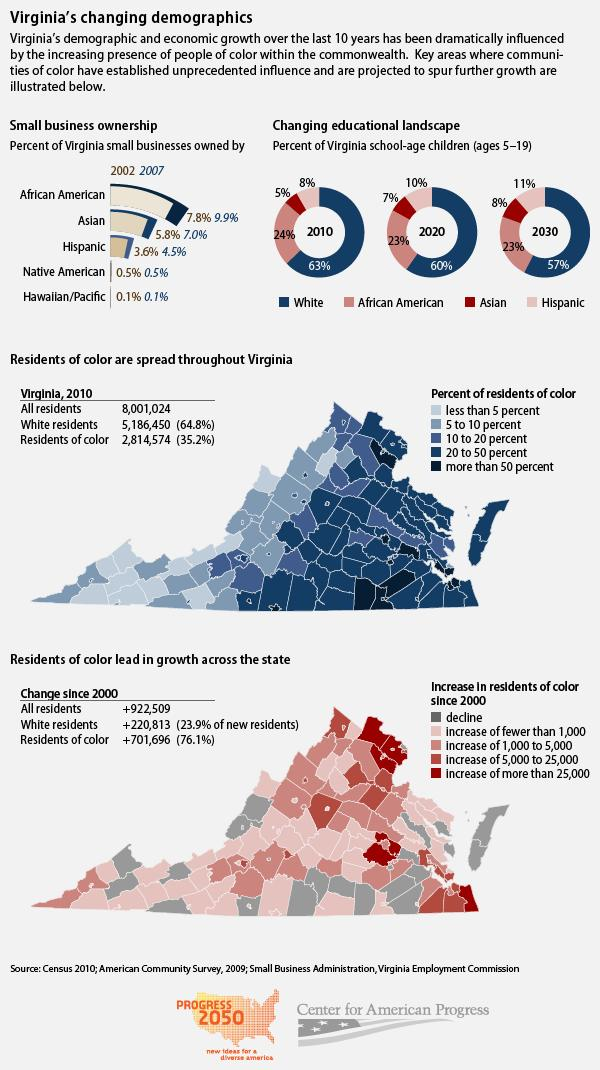Point out several critical features in this image. In 2002 and 2007, the percentage of small businesses owned by African Americans in Virginia was 17.7%. In 2020 and 2030, a combined total of 46% of Virginia's school-age children were African American. In 2002 and 2007, the percentage of Virginia small businesses owned by Asians was 12.8%. In 2010 and 2020, the percentage of Virginia school-age children who were Asians was 12%. In 2010 and 2020, the percentage of Virginia school-age children who are white is projected to have increased by 123%. 